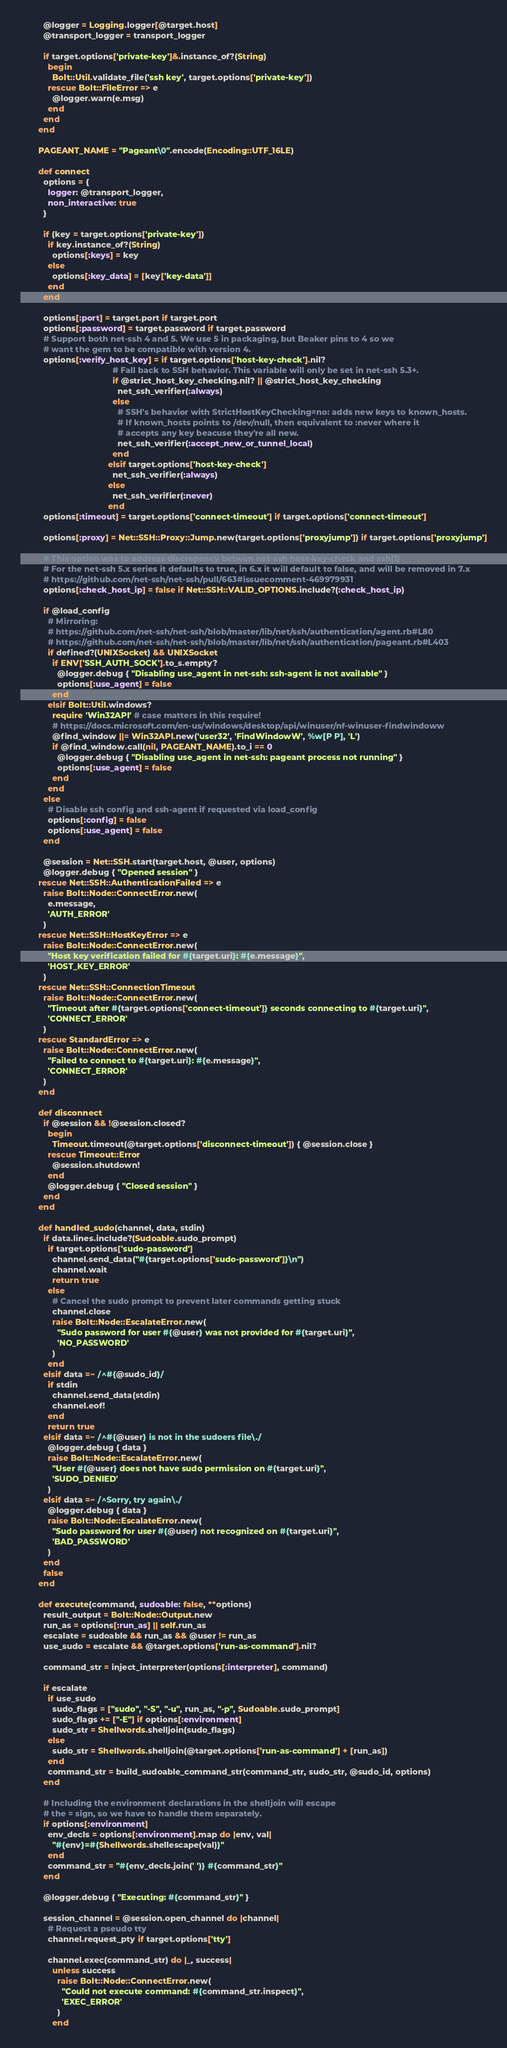Convert code to text. <code><loc_0><loc_0><loc_500><loc_500><_Ruby_>          @logger = Logging.logger[@target.host]
          @transport_logger = transport_logger

          if target.options['private-key']&.instance_of?(String)
            begin
              Bolt::Util.validate_file('ssh key', target.options['private-key'])
            rescue Bolt::FileError => e
              @logger.warn(e.msg)
            end
          end
        end

        PAGEANT_NAME = "Pageant\0".encode(Encoding::UTF_16LE)

        def connect
          options = {
            logger: @transport_logger,
            non_interactive: true
          }

          if (key = target.options['private-key'])
            if key.instance_of?(String)
              options[:keys] = key
            else
              options[:key_data] = [key['key-data']]
            end
          end

          options[:port] = target.port if target.port
          options[:password] = target.password if target.password
          # Support both net-ssh 4 and 5. We use 5 in packaging, but Beaker pins to 4 so we
          # want the gem to be compatible with version 4.
          options[:verify_host_key] = if target.options['host-key-check'].nil?
                                        # Fall back to SSH behavior. This variable will only be set in net-ssh 5.3+.
                                        if @strict_host_key_checking.nil? || @strict_host_key_checking
                                          net_ssh_verifier(:always)
                                        else
                                          # SSH's behavior with StrictHostKeyChecking=no: adds new keys to known_hosts.
                                          # If known_hosts points to /dev/null, then equivalent to :never where it
                                          # accepts any key beacuse they're all new.
                                          net_ssh_verifier(:accept_new_or_tunnel_local)
                                        end
                                      elsif target.options['host-key-check']
                                        net_ssh_verifier(:always)
                                      else
                                        net_ssh_verifier(:never)
                                      end
          options[:timeout] = target.options['connect-timeout'] if target.options['connect-timeout']

          options[:proxy] = Net::SSH::Proxy::Jump.new(target.options['proxyjump']) if target.options['proxyjump']

          # This option was to address discrepency betwen net-ssh host-key-check and ssh(1)
          # For the net-ssh 5.x series it defaults to true, in 6.x it will default to false, and will be removed in 7.x
          # https://github.com/net-ssh/net-ssh/pull/663#issuecomment-469979931
          options[:check_host_ip] = false if Net::SSH::VALID_OPTIONS.include?(:check_host_ip)

          if @load_config
            # Mirroring:
            # https://github.com/net-ssh/net-ssh/blob/master/lib/net/ssh/authentication/agent.rb#L80
            # https://github.com/net-ssh/net-ssh/blob/master/lib/net/ssh/authentication/pageant.rb#L403
            if defined?(UNIXSocket) && UNIXSocket
              if ENV['SSH_AUTH_SOCK'].to_s.empty?
                @logger.debug { "Disabling use_agent in net-ssh: ssh-agent is not available" }
                options[:use_agent] = false
              end
            elsif Bolt::Util.windows?
              require 'Win32API' # case matters in this require!
              # https://docs.microsoft.com/en-us/windows/desktop/api/winuser/nf-winuser-findwindoww
              @find_window ||= Win32API.new('user32', 'FindWindowW', %w[P P], 'L')
              if @find_window.call(nil, PAGEANT_NAME).to_i == 0
                @logger.debug { "Disabling use_agent in net-ssh: pageant process not running" }
                options[:use_agent] = false
              end
            end
          else
            # Disable ssh config and ssh-agent if requested via load_config
            options[:config] = false
            options[:use_agent] = false
          end

          @session = Net::SSH.start(target.host, @user, options)
          @logger.debug { "Opened session" }
        rescue Net::SSH::AuthenticationFailed => e
          raise Bolt::Node::ConnectError.new(
            e.message,
            'AUTH_ERROR'
          )
        rescue Net::SSH::HostKeyError => e
          raise Bolt::Node::ConnectError.new(
            "Host key verification failed for #{target.uri}: #{e.message}",
            'HOST_KEY_ERROR'
          )
        rescue Net::SSH::ConnectionTimeout
          raise Bolt::Node::ConnectError.new(
            "Timeout after #{target.options['connect-timeout']} seconds connecting to #{target.uri}",
            'CONNECT_ERROR'
          )
        rescue StandardError => e
          raise Bolt::Node::ConnectError.new(
            "Failed to connect to #{target.uri}: #{e.message}",
            'CONNECT_ERROR'
          )
        end

        def disconnect
          if @session && !@session.closed?
            begin
              Timeout.timeout(@target.options['disconnect-timeout']) { @session.close }
            rescue Timeout::Error
              @session.shutdown!
            end
            @logger.debug { "Closed session" }
          end
        end

        def handled_sudo(channel, data, stdin)
          if data.lines.include?(Sudoable.sudo_prompt)
            if target.options['sudo-password']
              channel.send_data("#{target.options['sudo-password']}\n")
              channel.wait
              return true
            else
              # Cancel the sudo prompt to prevent later commands getting stuck
              channel.close
              raise Bolt::Node::EscalateError.new(
                "Sudo password for user #{@user} was not provided for #{target.uri}",
                'NO_PASSWORD'
              )
            end
          elsif data =~ /^#{@sudo_id}/
            if stdin
              channel.send_data(stdin)
              channel.eof!
            end
            return true
          elsif data =~ /^#{@user} is not in the sudoers file\./
            @logger.debug { data }
            raise Bolt::Node::EscalateError.new(
              "User #{@user} does not have sudo permission on #{target.uri}",
              'SUDO_DENIED'
            )
          elsif data =~ /^Sorry, try again\./
            @logger.debug { data }
            raise Bolt::Node::EscalateError.new(
              "Sudo password for user #{@user} not recognized on #{target.uri}",
              'BAD_PASSWORD'
            )
          end
          false
        end

        def execute(command, sudoable: false, **options)
          result_output = Bolt::Node::Output.new
          run_as = options[:run_as] || self.run_as
          escalate = sudoable && run_as && @user != run_as
          use_sudo = escalate && @target.options['run-as-command'].nil?

          command_str = inject_interpreter(options[:interpreter], command)

          if escalate
            if use_sudo
              sudo_flags = ["sudo", "-S", "-u", run_as, "-p", Sudoable.sudo_prompt]
              sudo_flags += ["-E"] if options[:environment]
              sudo_str = Shellwords.shelljoin(sudo_flags)
            else
              sudo_str = Shellwords.shelljoin(@target.options['run-as-command'] + [run_as])
            end
            command_str = build_sudoable_command_str(command_str, sudo_str, @sudo_id, options)
          end

          # Including the environment declarations in the shelljoin will escape
          # the = sign, so we have to handle them separately.
          if options[:environment]
            env_decls = options[:environment].map do |env, val|
              "#{env}=#{Shellwords.shellescape(val)}"
            end
            command_str = "#{env_decls.join(' ')} #{command_str}"
          end

          @logger.debug { "Executing: #{command_str}" }

          session_channel = @session.open_channel do |channel|
            # Request a pseudo tty
            channel.request_pty if target.options['tty']

            channel.exec(command_str) do |_, success|
              unless success
                raise Bolt::Node::ConnectError.new(
                  "Could not execute command: #{command_str.inspect}",
                  'EXEC_ERROR'
                )
              end
</code> 